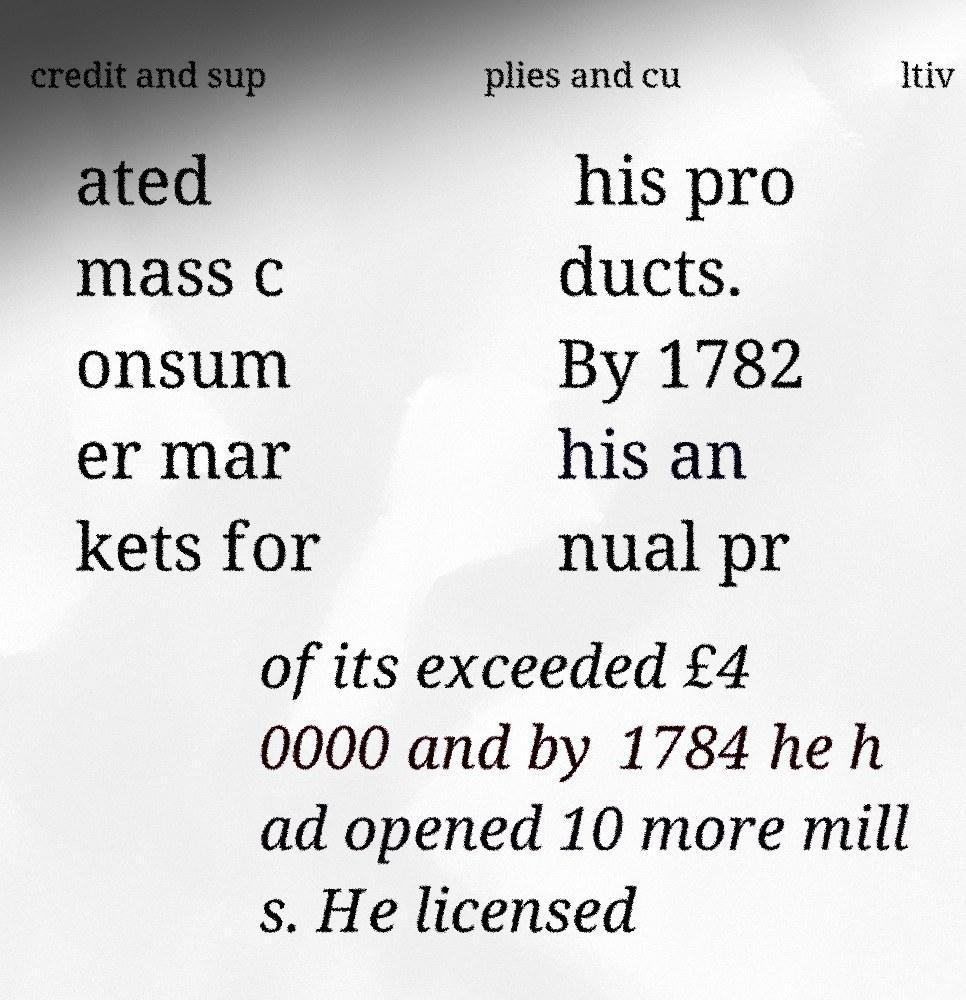Could you assist in decoding the text presented in this image and type it out clearly? credit and sup plies and cu ltiv ated mass c onsum er mar kets for his pro ducts. By 1782 his an nual pr ofits exceeded £4 0000 and by 1784 he h ad opened 10 more mill s. He licensed 